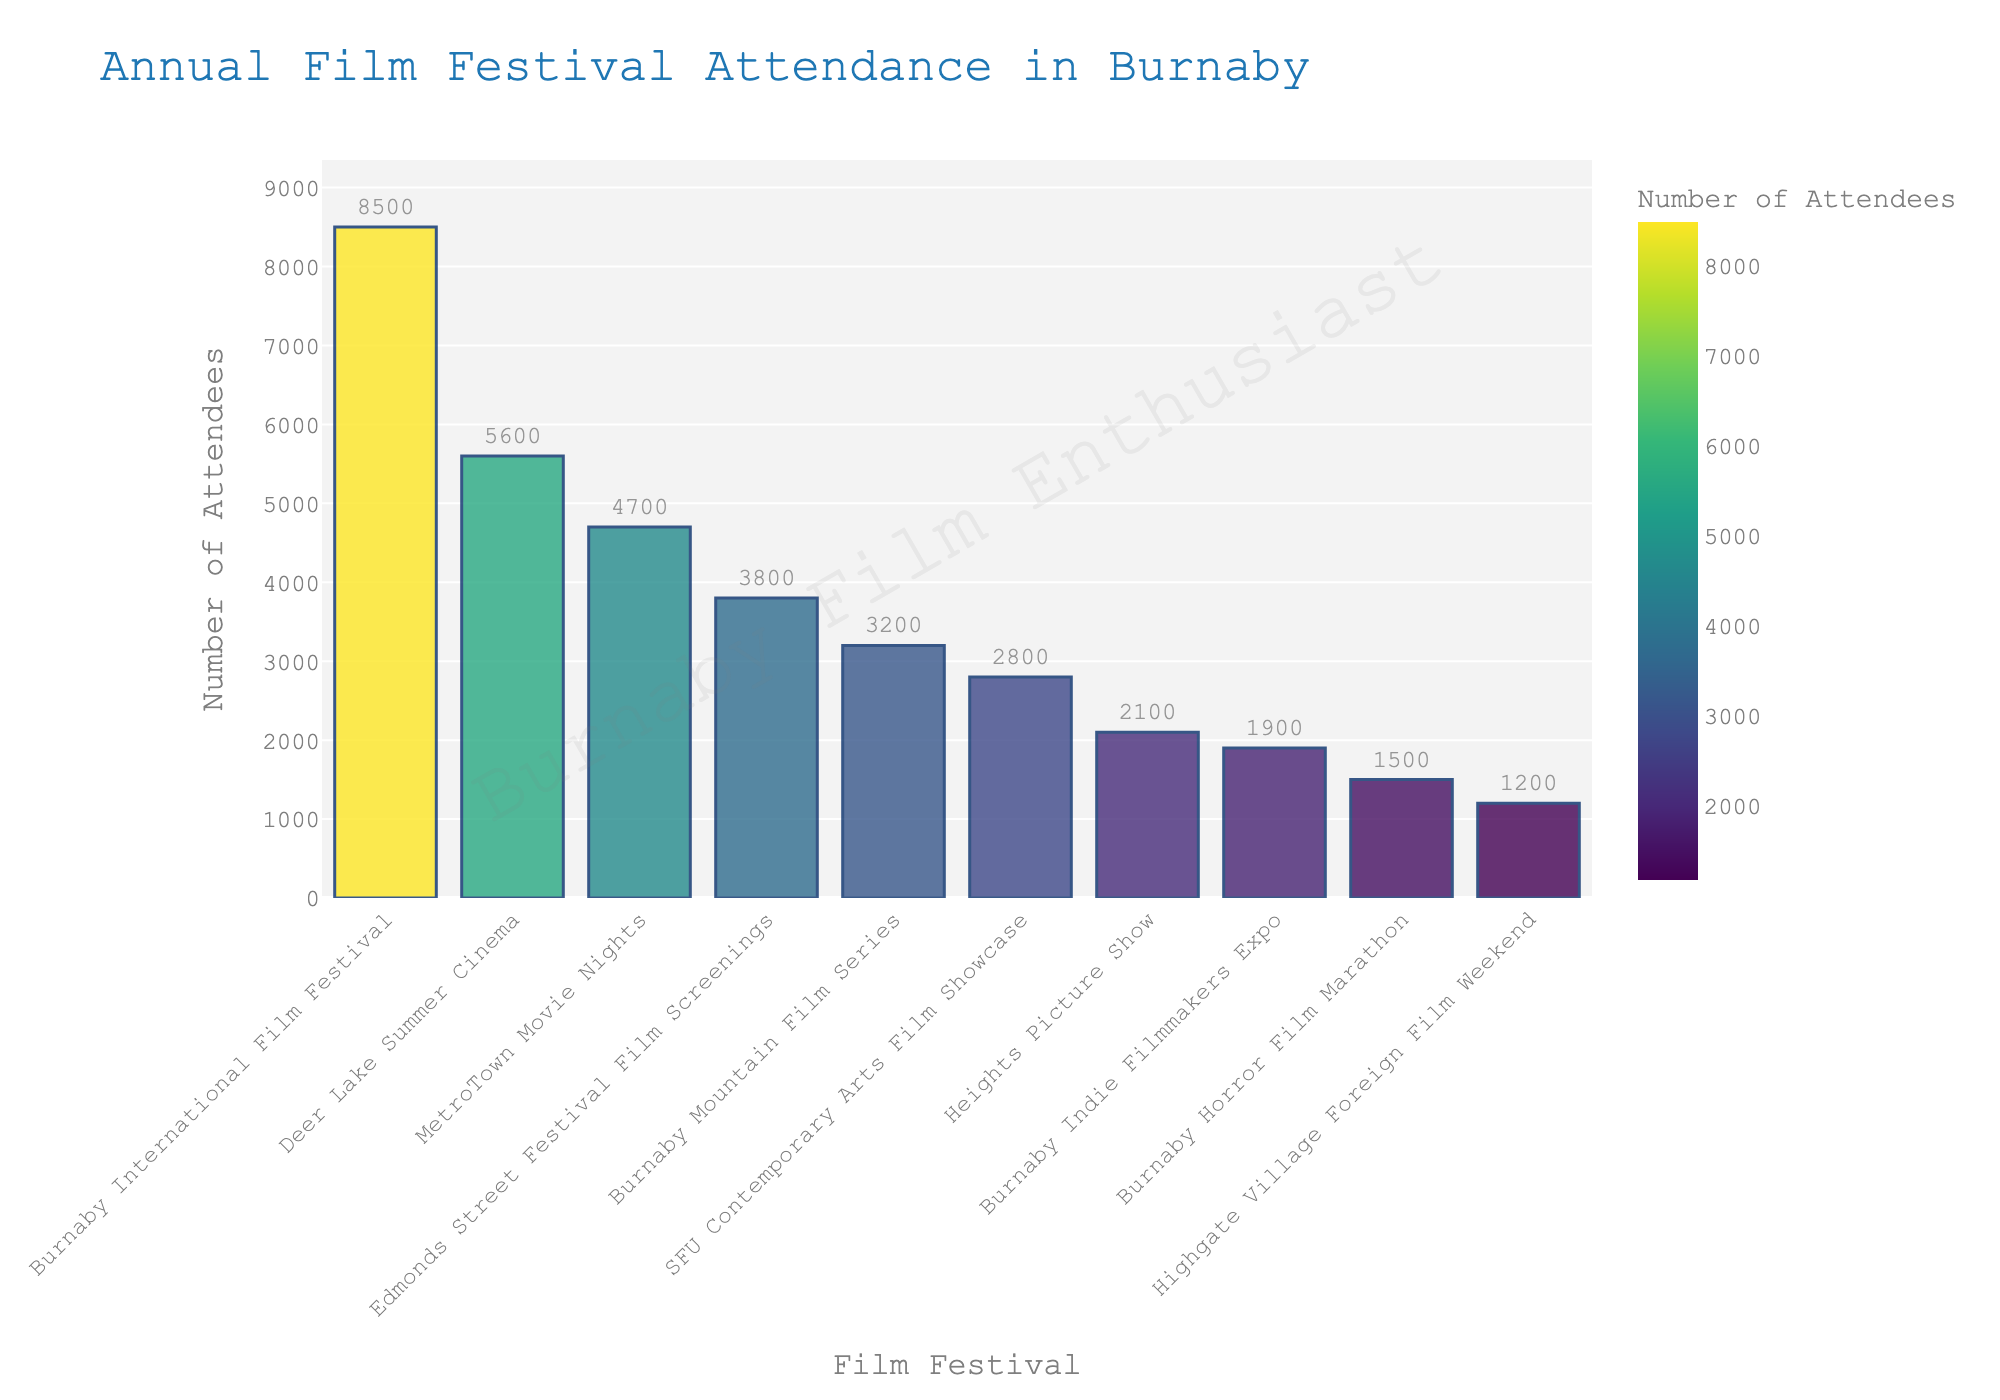Which event has the highest attendance? By observing the bar chart, the tallest bar represents the event with the highest attendance, which is the Burnaby International Film Festival.
Answer: Burnaby International Film Festival Which two events have the lowest attendance? The shortest two bars represent the events with the lowest attendance, which are the Highgate Village Foreign Film Weekend and the Burnaby Horror Film Marathon.
Answer: Highgate Village Foreign Film Weekend, Burnaby Horror Film Marathon What is the total attendance of the Burnaby Mountain Film Series and the Deer Lake Summer Cinema? The attendance for the Burnaby Mountain Film Series is 3200 and for the Deer Lake Summer Cinema is 5600. Summing these gives 3200 + 5600 = 8800.
Answer: 8800 Which event has a higher attendance: MetroTown Movie Nights or SFU Contemporary Arts Film Showcase? Comparing the respective bars, MetroTown Movie Nights has 4700 attendees, while SFU Contemporary Arts Film Showcase has 2800 attendees. So, MetroTown Movie Nights has higher attendance.
Answer: MetroTown Movie Nights What is the difference in attendance between Edmonds Street Festival Film Screenings and Heights Picture Show? The attendance for Edmonds Street Festival Film Screenings is 3800 and for Heights Picture Show is 2100. Subtracting these gives 3800 - 2100 = 1700.
Answer: 1700 What is the average attendance of all the events? Summing all the attendances: 8500 + 3200 + 2800 + 5600 + 1900 + 4700 + 3800 + 2100 + 1500 + 1200 = 35300. The total number of events is 10. So, the average is 35300 / 10 = 3530.
Answer: 3530 Which event's bar appears in the middle when events are sorted by attendance? When sorted by attendance, the middle event (5th and 6th in list) is MetroTown Movie Nights and Edmonds Street Festival Film Screenings.
Answer: MetroTown Movie Nights, Edmonds Street Festival Film Screenings How much more is the attendance of the highest-attended event compared to the lowest-attended event? The highest attendance is 8500 (Burnaby International Film Festival), and the lowest is 1200 (Highgate Village Foreign Film Weekend). Subtracting these gives 8500 - 1200 = 7300.
Answer: 7300 